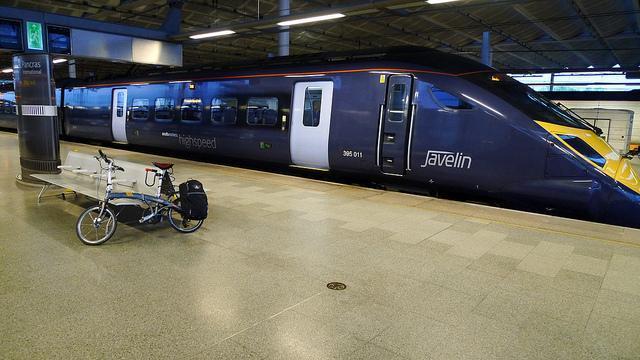How many toilets are there?
Give a very brief answer. 0. 